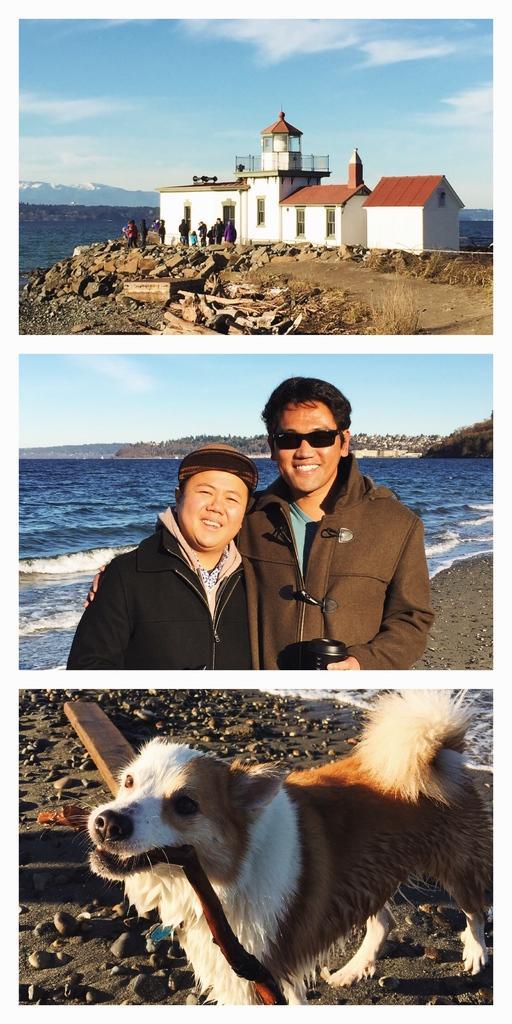Describe this image in one or two sentences. In this image there is a collage of 3 images. On the top there is a building and there are persons in front of the building and the sky is cloudy and there is a water. In the middle there are two persons standing and smiling. In the background there is a water and the sky is cloudy. At the bottom there is a dog holding an object in its mouth and there is a water in the background and on the ground there are stones. 